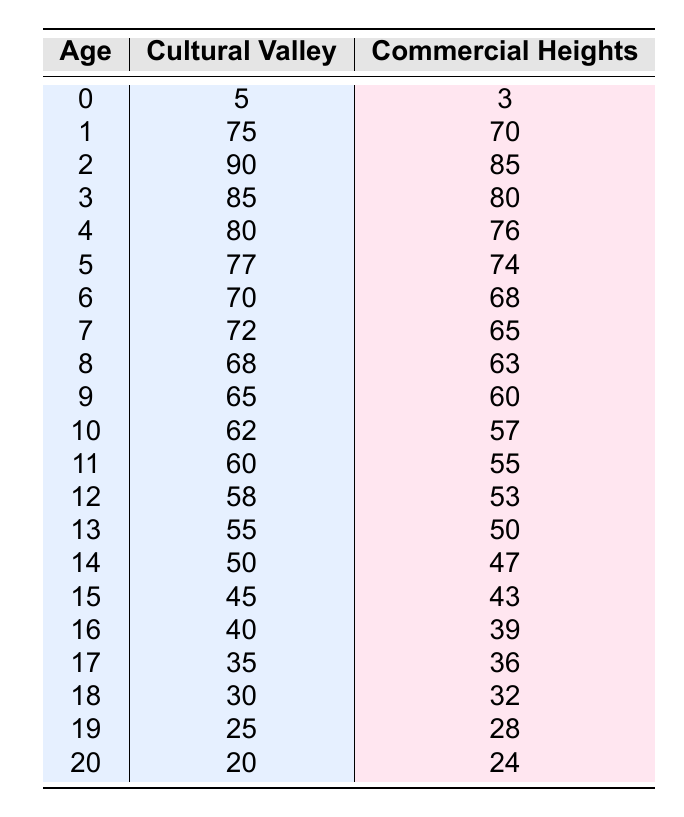What is the age at death for a 2-year-old in Cultural Valley? The table shows that the age at death for a 2-year-old in Cultural Valley is listed directly under the corresponding column for that community.
Answer: 90 Which community has a higher age at death for 5-year-olds? The age at death for 5-year-olds is 77 in Cultural Valley and 74 in Commercial Heights. Since 77 is greater than 74, Cultural Valley has a higher age at death for 5-year-olds.
Answer: Cultural Valley What is the age at death difference for 15-year-olds between the two communities? The age at death for 15-year-olds in Cultural Valley is 45, while in Commercial Heights, it is 43. The difference is calculated as 45 - 43 = 2.
Answer: 2 Is the age at death for 19-year-olds higher in Commercial Heights than Cultural Valley? For 19-year-olds, the age at death is 28 in Commercial Heights and 25 in Cultural Valley. Since 28 is greater than 25, the statement is true.
Answer: Yes What is the average age at death for 10-year-olds in both communities? To find the average age at death for 10-year-olds, we take the values from both communities: 62 (Cultural Valley) and 57 (Commercial Heights). The sum is 62 + 57 = 119, and then we divide by 2, giving us 119 / 2 = 59.5.
Answer: 59.5 How many age groups have a higher age at death in Cultural Valley when compared to Commercial Heights? Examining the table, we compare each row: Cultural Valley has higher ages at death for ages 0, 1, 2, 3, 4, 5, 6, 7, 8, 9, 10, 11, 12, 13, 14, and 15. This totals to 16 age groups.
Answer: 16 What is the highest age at death recorded in Commercial Heights, and at what age does it occur? The highest age at death in Commercial Heights is 85, which occurs for 2-year-olds. Looking at the table, this value stands out in the respective row.
Answer: 85 at age 2 Which community shows a trend of lower age at death for older age groups? In the table, as age increases, Commercial Heights consistently shows lower ages at death compared to Cultural Valley, particularly evident for ages 15 and older.
Answer: Commercial Heights What is the cumulative age at death for the first five age groups in Cultural Valley? The age at death for the first five groups in Cultural Valley is 5, 75, 90, 85, and 80. Adding these together gives us 5 + 75 + 90 + 85 + 80 = 335.
Answer: 335 